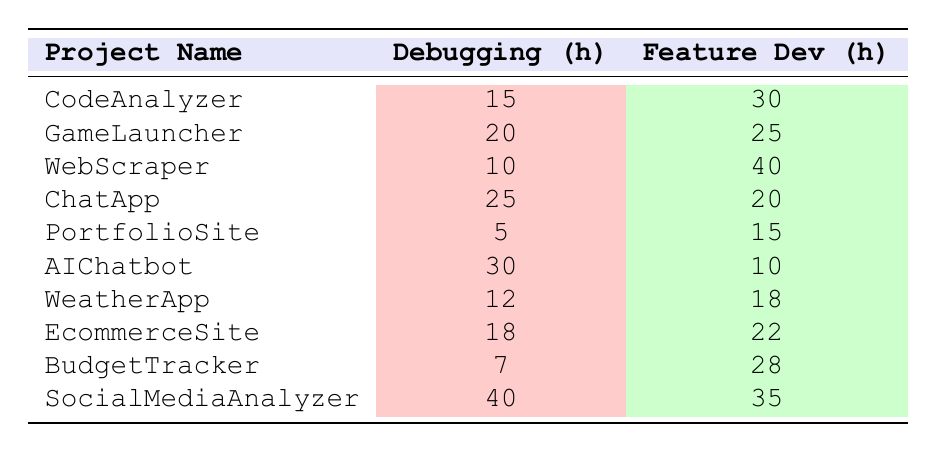What is the project with the highest time spent on debugging? By scanning the "Debugging (h)" column, the highest value is 40 hours, which corresponds to the project "SocialMediaAnalyzer."
Answer: SocialMediaAnalyzer What is the project with the least amount of time spent on feature development? Looking at the "Feature Dev (h)" column, the lowest time spent is 10 hours, associated with the project "AIChatbot."
Answer: AIChatbot How much total time was spent on debugging across all projects? To find the total time spent on debugging, add the debugging hours for each project: 15 + 20 + 10 + 25 + 5 + 30 + 12 + 18 + 7 + 40 =  182 hours.
Answer: 182 What is the difference in time spent on debugging and feature development for the project "WeatherApp"? For "WeatherApp," the time spent on debugging is 12 hours and on feature development is 18 hours. The difference is 18 - 12 = 6 hours.
Answer: 6 What is the average time spent on feature development among all projects? To calculate the average, first sum the feature development hours: 30 + 25 + 40 + 20 + 15 + 10 + 18 + 22 + 28 + 35 =  303 hours. There are 10 projects, so the average is 303 / 10 = 30.3 hours.
Answer: 30.3 Is there any project where the time spent on debugging is greater than the time spent on feature development? Yes, by comparing the values for each project, "ChatApp" (25 vs. 20) and "AIChatbot" (30 vs. 10) show debugging time greater than feature development time.
Answer: Yes Which project has the highest feature development time and what is the value? The project with the highest feature development time is "WebScraper" with 40 hours, as seen in the "Feature Dev (h)" column.
Answer: WebScraper, 40 If we consider "BudgetTracker," how much more time was spent on feature development compared to debugging? For "BudgetTracker," time spent on debugging is 7 hours and on feature development is 28 hours. The difference is 28 - 7 = 21 hours more spent on feature development.
Answer: 21 How many projects spent more time on debugging than 15 hours? From the table, the projects "GameLauncher," "ChatApp," "AIChatbot," "SocialMediaAnalyzer," and "EcommerceSite" spent more than 15 hours debugging, giving us a total of 5 projects.
Answer: 5 What is the total time spent on both debugging and feature development for the project "CodeAnalyzer"? For "CodeAnalyzer," add the debugging time (15 hours) and feature development time (30 hours) together: 15 + 30 = 45 hours in total.
Answer: 45 